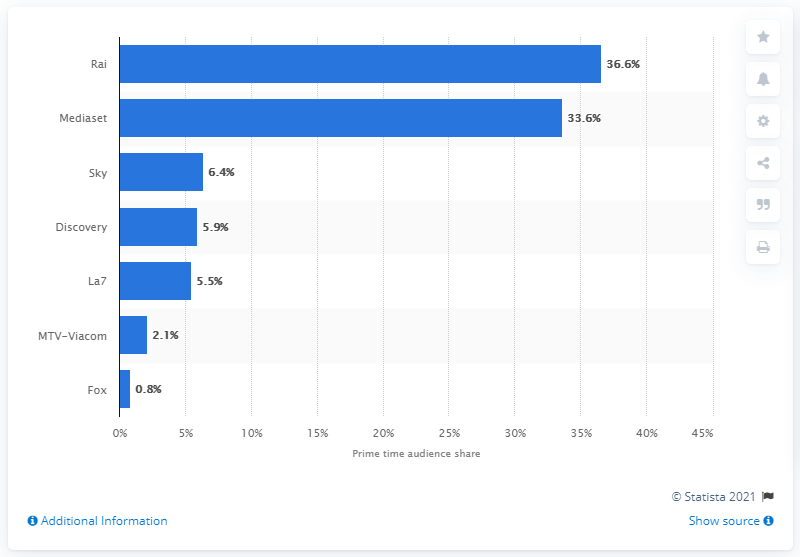Draw attention to some important aspects in this diagram. According to data from the Italian market in the first half of 2020, the Italian public broadcasting company that recorded the highest audience share in prime time was Rai. Mediaset, the Italian broadcaster, had the highest audience share during prime time. 